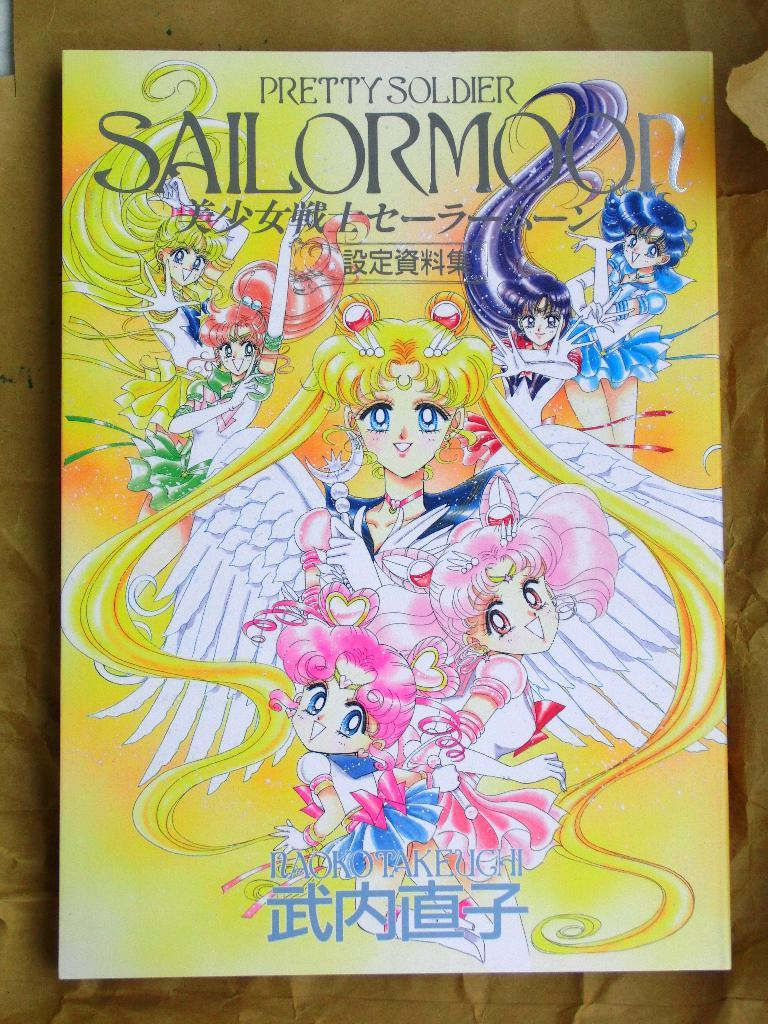<image>
Relay a brief, clear account of the picture shown. Cover of an anime that says Pretty Soldier Sailor Moon on top. 